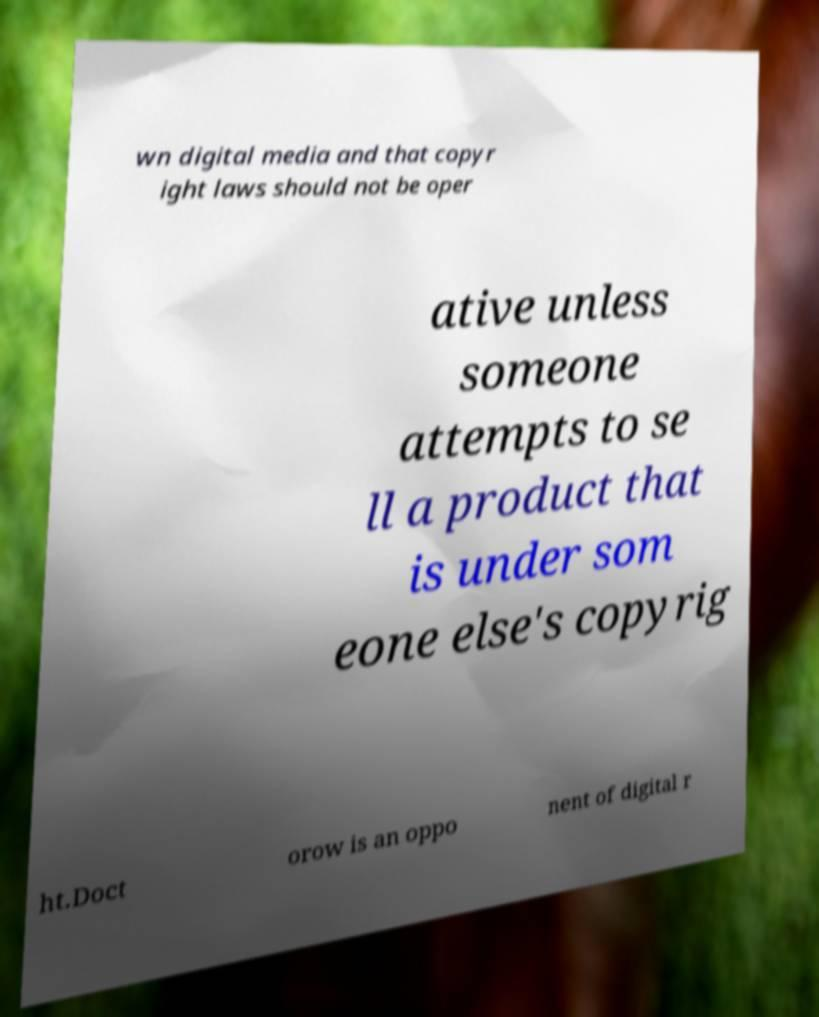Could you extract and type out the text from this image? wn digital media and that copyr ight laws should not be oper ative unless someone attempts to se ll a product that is under som eone else's copyrig ht.Doct orow is an oppo nent of digital r 